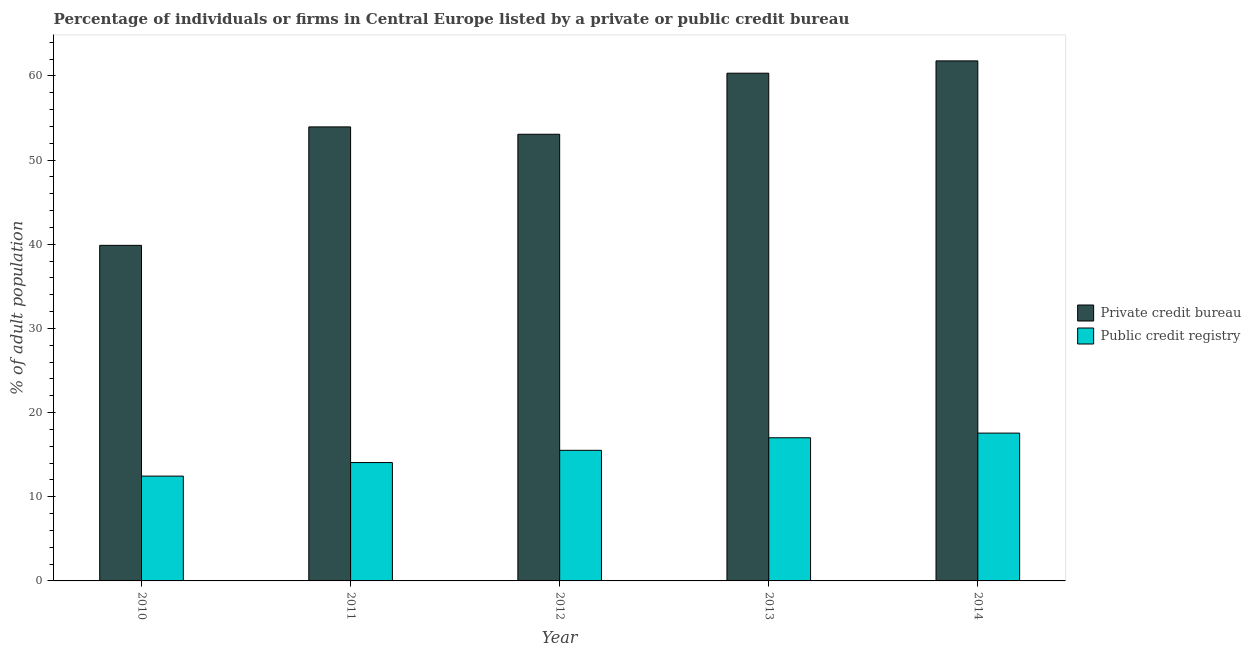How many groups of bars are there?
Your response must be concise. 5. Are the number of bars per tick equal to the number of legend labels?
Provide a succinct answer. Yes. Are the number of bars on each tick of the X-axis equal?
Your answer should be very brief. Yes. How many bars are there on the 1st tick from the right?
Your answer should be compact. 2. In how many cases, is the number of bars for a given year not equal to the number of legend labels?
Make the answer very short. 0. What is the percentage of firms listed by public credit bureau in 2013?
Your answer should be compact. 17.01. Across all years, what is the maximum percentage of firms listed by private credit bureau?
Your answer should be compact. 61.79. Across all years, what is the minimum percentage of firms listed by private credit bureau?
Keep it short and to the point. 39.87. What is the total percentage of firms listed by private credit bureau in the graph?
Ensure brevity in your answer.  269.01. What is the difference between the percentage of firms listed by public credit bureau in 2010 and that in 2011?
Offer a terse response. -1.61. What is the difference between the percentage of firms listed by private credit bureau in 2012 and the percentage of firms listed by public credit bureau in 2014?
Ensure brevity in your answer.  -8.72. What is the average percentage of firms listed by public credit bureau per year?
Ensure brevity in your answer.  15.32. In the year 2010, what is the difference between the percentage of firms listed by private credit bureau and percentage of firms listed by public credit bureau?
Make the answer very short. 0. In how many years, is the percentage of firms listed by private credit bureau greater than 54 %?
Your answer should be compact. 2. What is the ratio of the percentage of firms listed by public credit bureau in 2012 to that in 2014?
Make the answer very short. 0.88. Is the percentage of firms listed by public credit bureau in 2012 less than that in 2013?
Offer a very short reply. Yes. Is the difference between the percentage of firms listed by public credit bureau in 2012 and 2013 greater than the difference between the percentage of firms listed by private credit bureau in 2012 and 2013?
Your answer should be very brief. No. What is the difference between the highest and the second highest percentage of firms listed by private credit bureau?
Give a very brief answer. 1.46. What is the difference between the highest and the lowest percentage of firms listed by private credit bureau?
Give a very brief answer. 21.92. What does the 1st bar from the left in 2014 represents?
Keep it short and to the point. Private credit bureau. What does the 2nd bar from the right in 2012 represents?
Offer a very short reply. Private credit bureau. How many bars are there?
Make the answer very short. 10. What is the difference between two consecutive major ticks on the Y-axis?
Your answer should be compact. 10. Are the values on the major ticks of Y-axis written in scientific E-notation?
Give a very brief answer. No. Does the graph contain any zero values?
Your answer should be compact. No. What is the title of the graph?
Offer a very short reply. Percentage of individuals or firms in Central Europe listed by a private or public credit bureau. What is the label or title of the Y-axis?
Your response must be concise. % of adult population. What is the % of adult population of Private credit bureau in 2010?
Give a very brief answer. 39.87. What is the % of adult population in Public credit registry in 2010?
Your response must be concise. 12.45. What is the % of adult population in Private credit bureau in 2011?
Your response must be concise. 53.95. What is the % of adult population in Public credit registry in 2011?
Ensure brevity in your answer.  14.06. What is the % of adult population of Private credit bureau in 2012?
Provide a succinct answer. 53.07. What is the % of adult population in Public credit registry in 2012?
Ensure brevity in your answer.  15.52. What is the % of adult population in Private credit bureau in 2013?
Make the answer very short. 60.33. What is the % of adult population of Public credit registry in 2013?
Give a very brief answer. 17.01. What is the % of adult population of Private credit bureau in 2014?
Ensure brevity in your answer.  61.79. What is the % of adult population of Public credit registry in 2014?
Offer a terse response. 17.56. Across all years, what is the maximum % of adult population in Private credit bureau?
Provide a short and direct response. 61.79. Across all years, what is the maximum % of adult population of Public credit registry?
Your answer should be compact. 17.56. Across all years, what is the minimum % of adult population in Private credit bureau?
Your response must be concise. 39.87. Across all years, what is the minimum % of adult population of Public credit registry?
Provide a short and direct response. 12.45. What is the total % of adult population of Private credit bureau in the graph?
Make the answer very short. 269.01. What is the total % of adult population in Public credit registry in the graph?
Provide a short and direct response. 76.61. What is the difference between the % of adult population in Private credit bureau in 2010 and that in 2011?
Keep it short and to the point. -14.07. What is the difference between the % of adult population of Public credit registry in 2010 and that in 2011?
Keep it short and to the point. -1.61. What is the difference between the % of adult population of Private credit bureau in 2010 and that in 2012?
Make the answer very short. -13.2. What is the difference between the % of adult population of Public credit registry in 2010 and that in 2012?
Offer a very short reply. -3.06. What is the difference between the % of adult population of Private credit bureau in 2010 and that in 2013?
Offer a terse response. -20.45. What is the difference between the % of adult population in Public credit registry in 2010 and that in 2013?
Your answer should be compact. -4.55. What is the difference between the % of adult population in Private credit bureau in 2010 and that in 2014?
Provide a succinct answer. -21.92. What is the difference between the % of adult population in Public credit registry in 2010 and that in 2014?
Make the answer very short. -5.11. What is the difference between the % of adult population of Private credit bureau in 2011 and that in 2012?
Provide a short and direct response. 0.87. What is the difference between the % of adult population in Public credit registry in 2011 and that in 2012?
Your response must be concise. -1.45. What is the difference between the % of adult population in Private credit bureau in 2011 and that in 2013?
Offer a terse response. -6.38. What is the difference between the % of adult population of Public credit registry in 2011 and that in 2013?
Your answer should be compact. -2.95. What is the difference between the % of adult population in Private credit bureau in 2011 and that in 2014?
Provide a succinct answer. -7.85. What is the difference between the % of adult population in Private credit bureau in 2012 and that in 2013?
Your response must be concise. -7.25. What is the difference between the % of adult population in Public credit registry in 2012 and that in 2013?
Give a very brief answer. -1.49. What is the difference between the % of adult population of Private credit bureau in 2012 and that in 2014?
Ensure brevity in your answer.  -8.72. What is the difference between the % of adult population in Public credit registry in 2012 and that in 2014?
Your response must be concise. -2.05. What is the difference between the % of adult population in Private credit bureau in 2013 and that in 2014?
Ensure brevity in your answer.  -1.46. What is the difference between the % of adult population in Public credit registry in 2013 and that in 2014?
Your answer should be compact. -0.55. What is the difference between the % of adult population of Private credit bureau in 2010 and the % of adult population of Public credit registry in 2011?
Provide a succinct answer. 25.81. What is the difference between the % of adult population of Private credit bureau in 2010 and the % of adult population of Public credit registry in 2012?
Offer a very short reply. 24.35. What is the difference between the % of adult population of Private credit bureau in 2010 and the % of adult population of Public credit registry in 2013?
Give a very brief answer. 22.86. What is the difference between the % of adult population in Private credit bureau in 2010 and the % of adult population in Public credit registry in 2014?
Your answer should be compact. 22.31. What is the difference between the % of adult population of Private credit bureau in 2011 and the % of adult population of Public credit registry in 2012?
Ensure brevity in your answer.  38.43. What is the difference between the % of adult population of Private credit bureau in 2011 and the % of adult population of Public credit registry in 2013?
Ensure brevity in your answer.  36.94. What is the difference between the % of adult population in Private credit bureau in 2011 and the % of adult population in Public credit registry in 2014?
Your answer should be very brief. 36.38. What is the difference between the % of adult population of Private credit bureau in 2012 and the % of adult population of Public credit registry in 2013?
Make the answer very short. 36.06. What is the difference between the % of adult population of Private credit bureau in 2012 and the % of adult population of Public credit registry in 2014?
Your answer should be very brief. 35.51. What is the difference between the % of adult population of Private credit bureau in 2013 and the % of adult population of Public credit registry in 2014?
Keep it short and to the point. 42.76. What is the average % of adult population in Private credit bureau per year?
Make the answer very short. 53.8. What is the average % of adult population of Public credit registry per year?
Your answer should be very brief. 15.32. In the year 2010, what is the difference between the % of adult population in Private credit bureau and % of adult population in Public credit registry?
Keep it short and to the point. 27.42. In the year 2011, what is the difference between the % of adult population in Private credit bureau and % of adult population in Public credit registry?
Give a very brief answer. 39.88. In the year 2012, what is the difference between the % of adult population of Private credit bureau and % of adult population of Public credit registry?
Provide a succinct answer. 37.55. In the year 2013, what is the difference between the % of adult population of Private credit bureau and % of adult population of Public credit registry?
Keep it short and to the point. 43.32. In the year 2014, what is the difference between the % of adult population in Private credit bureau and % of adult population in Public credit registry?
Your answer should be compact. 44.23. What is the ratio of the % of adult population of Private credit bureau in 2010 to that in 2011?
Your response must be concise. 0.74. What is the ratio of the % of adult population of Public credit registry in 2010 to that in 2011?
Make the answer very short. 0.89. What is the ratio of the % of adult population in Private credit bureau in 2010 to that in 2012?
Your response must be concise. 0.75. What is the ratio of the % of adult population of Public credit registry in 2010 to that in 2012?
Provide a short and direct response. 0.8. What is the ratio of the % of adult population in Private credit bureau in 2010 to that in 2013?
Your answer should be compact. 0.66. What is the ratio of the % of adult population of Public credit registry in 2010 to that in 2013?
Your response must be concise. 0.73. What is the ratio of the % of adult population in Private credit bureau in 2010 to that in 2014?
Offer a terse response. 0.65. What is the ratio of the % of adult population in Public credit registry in 2010 to that in 2014?
Ensure brevity in your answer.  0.71. What is the ratio of the % of adult population of Private credit bureau in 2011 to that in 2012?
Keep it short and to the point. 1.02. What is the ratio of the % of adult population in Public credit registry in 2011 to that in 2012?
Your response must be concise. 0.91. What is the ratio of the % of adult population in Private credit bureau in 2011 to that in 2013?
Make the answer very short. 0.89. What is the ratio of the % of adult population of Public credit registry in 2011 to that in 2013?
Your answer should be very brief. 0.83. What is the ratio of the % of adult population in Private credit bureau in 2011 to that in 2014?
Give a very brief answer. 0.87. What is the ratio of the % of adult population of Public credit registry in 2011 to that in 2014?
Ensure brevity in your answer.  0.8. What is the ratio of the % of adult population in Private credit bureau in 2012 to that in 2013?
Your answer should be very brief. 0.88. What is the ratio of the % of adult population in Public credit registry in 2012 to that in 2013?
Give a very brief answer. 0.91. What is the ratio of the % of adult population in Private credit bureau in 2012 to that in 2014?
Keep it short and to the point. 0.86. What is the ratio of the % of adult population in Public credit registry in 2012 to that in 2014?
Your response must be concise. 0.88. What is the ratio of the % of adult population of Private credit bureau in 2013 to that in 2014?
Make the answer very short. 0.98. What is the ratio of the % of adult population of Public credit registry in 2013 to that in 2014?
Your answer should be very brief. 0.97. What is the difference between the highest and the second highest % of adult population in Private credit bureau?
Offer a very short reply. 1.46. What is the difference between the highest and the second highest % of adult population of Public credit registry?
Give a very brief answer. 0.55. What is the difference between the highest and the lowest % of adult population in Private credit bureau?
Make the answer very short. 21.92. What is the difference between the highest and the lowest % of adult population in Public credit registry?
Your response must be concise. 5.11. 